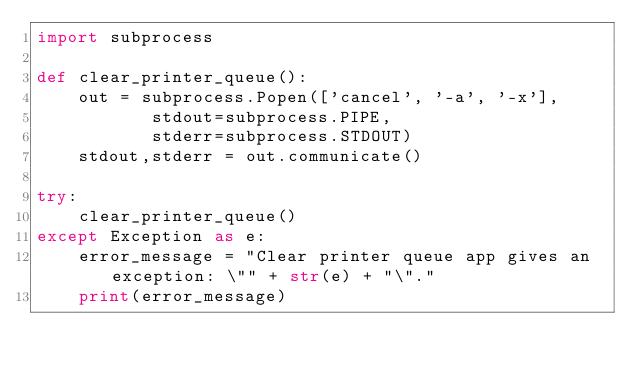<code> <loc_0><loc_0><loc_500><loc_500><_Python_>import subprocess

def clear_printer_queue():
    out = subprocess.Popen(['cancel', '-a', '-x'], 
           stdout=subprocess.PIPE, 
           stderr=subprocess.STDOUT)
    stdout,stderr = out.communicate()

try:
    clear_printer_queue()
except Exception as e:
    error_message = "Clear printer queue app gives an exception: \"" + str(e) + "\"."
    print(error_message)</code> 